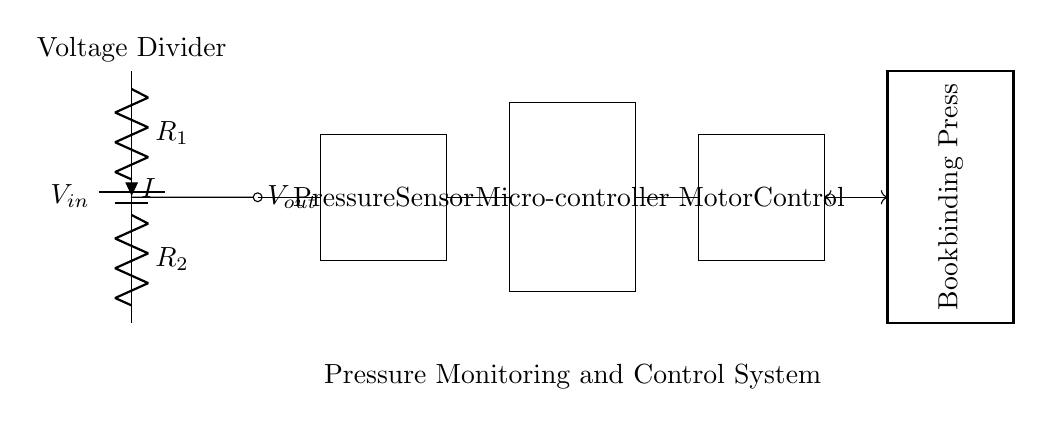What is the function of the component labeled R1? R1 is a resistor that forms part of the voltage divider, helping to divide the input voltage into a lower output voltage.
Answer: Resistor What connects the output voltage to the pressure sensor? The output voltage is connected to the pressure sensor by a wire, ensuring that the voltage is used to monitor the pressure.
Answer: Wire What is the label of the microcontroller? The microcontroller is labeled as "Microcontroller" in the circuit diagram, indicating its role in processing the output from the pressure sensor.
Answer: Microcontroller How many resistors are used in the voltage divider? There are two resistors in the voltage divider, designated as R1 and R2, which work together to divide the input voltage.
Answer: Two What is the role of the motor control component? The motor control component is responsible for regulating the movement of the bookbinding press based on the microcontroller's output.
Answer: Regulation What is the relationship between the pressure sensor and the microcontroller? The pressure sensor sends readings to the microcontroller, which processes the data and determines if adjustments to the pressure are needed.
Answer: Sending readings What type of circuit is utilized in this design? This design uses a voltage divider circuit, which is specifically built to lower voltage and allow for pressure monitoring within the system.
Answer: Voltage divider 